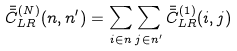<formula> <loc_0><loc_0><loc_500><loc_500>\bar { \bar { C } } _ { L R } ^ { ( N ) } ( n , n ^ { \prime } ) = \sum _ { i \in n } \sum _ { j \in n ^ { \prime } } \bar { \bar { C } } _ { L R } ^ { ( 1 ) } ( i , j )</formula> 